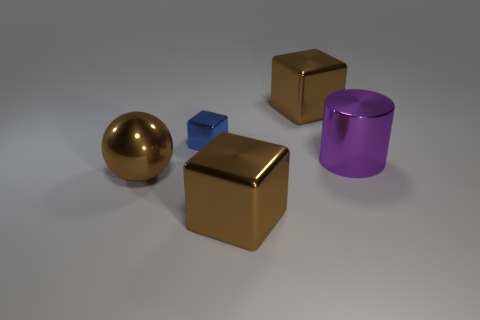Add 2 spheres. How many objects exist? 7 Subtract all cylinders. How many objects are left? 4 Add 1 big red spheres. How many big red spheres exist? 1 Subtract 0 purple cubes. How many objects are left? 5 Subtract all tiny blue cylinders. Subtract all small cubes. How many objects are left? 4 Add 3 brown metallic things. How many brown metallic things are left? 6 